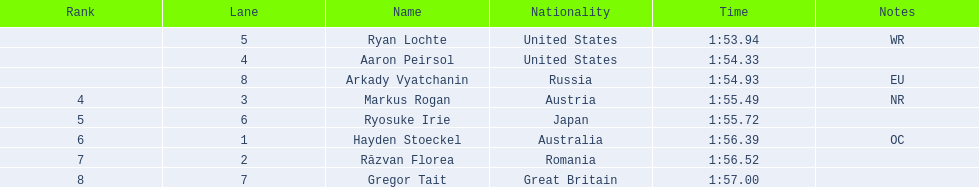Who were the event's participants? Ryan Lochte, Aaron Peirsol, Arkady Vyatchanin, Markus Rogan, Ryosuke Irie, Hayden Stoeckel, Răzvan Florea, Gregor Tait. Can you list the finishing times of all the athletes? 1:53.94, 1:54.33, 1:54.93, 1:55.49, 1:55.72, 1:56.39, 1:56.52, 1:57.00. Also, what was ryosuke irie's finishing time? 1:55.72. 